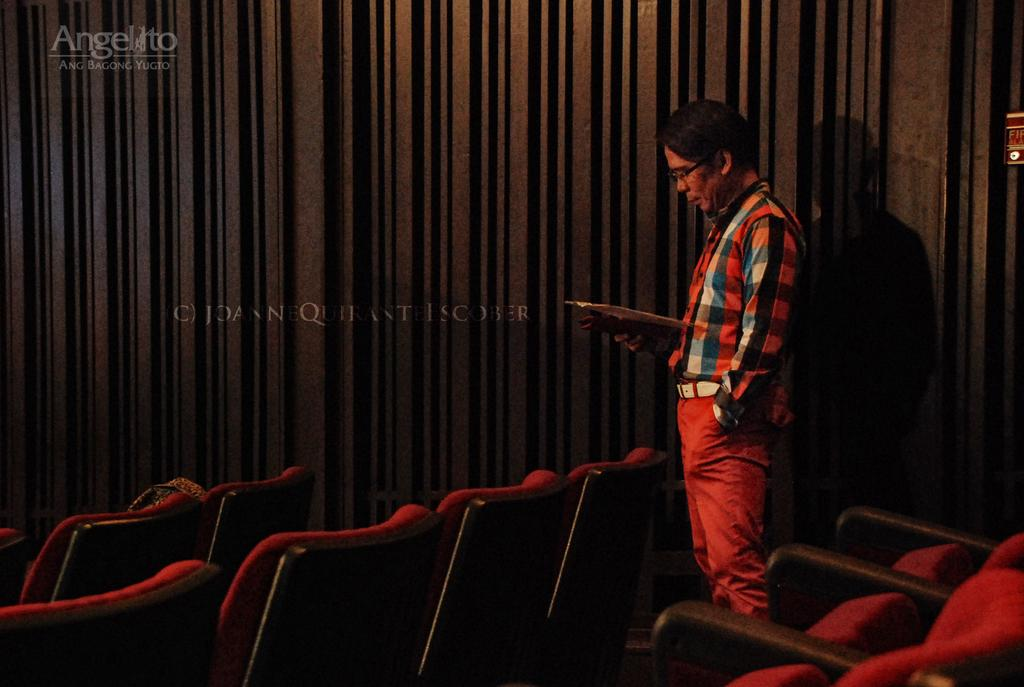Who is present in the image? There is a man in the image. What is the man doing in the image? The man is standing near chairs in the image. Can you describe the position of the chairs in relation to the man? The chairs are in front of the man. What can be seen in the background of the image? There is a wall with a design in the background of the image. What is the man holding in the image? The man is holding papers in the image. What type of song can be heard playing in the background of the image? There is no song playing in the background of the image; it is a still image. What scent is associated with the man in the image? There is no information about the scent associated with the man in the image. 